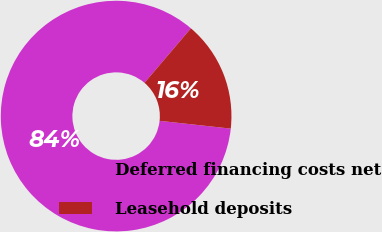Convert chart to OTSL. <chart><loc_0><loc_0><loc_500><loc_500><pie_chart><fcel>Deferred financing costs net<fcel>Leasehold deposits<nl><fcel>84.5%<fcel>15.5%<nl></chart> 